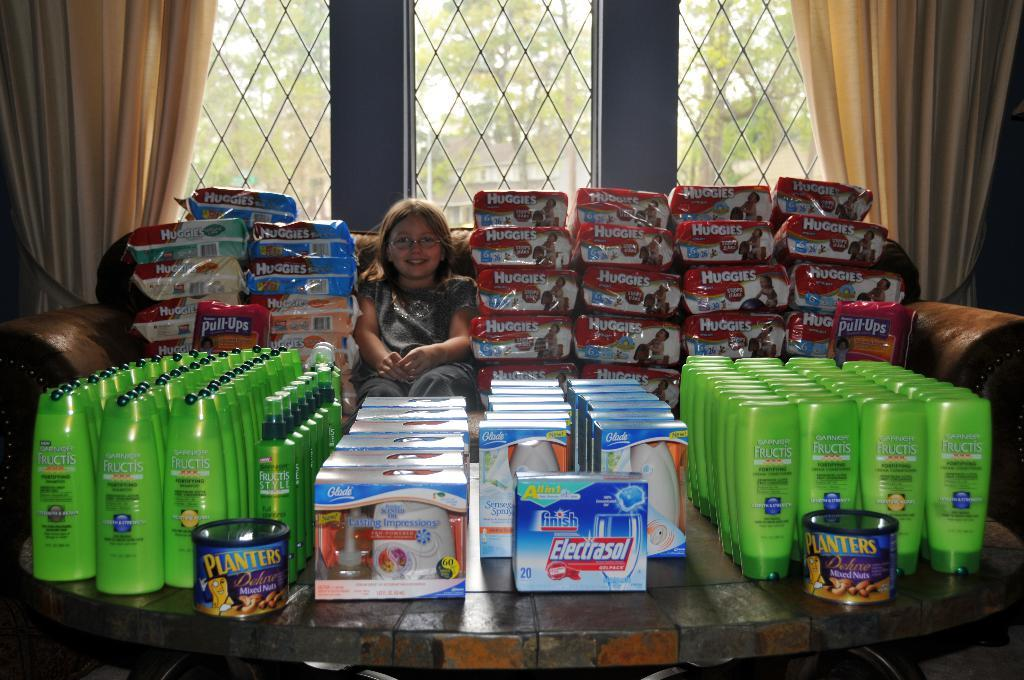<image>
Present a compact description of the photo's key features. A large stack of products including huggies and electrasol. 